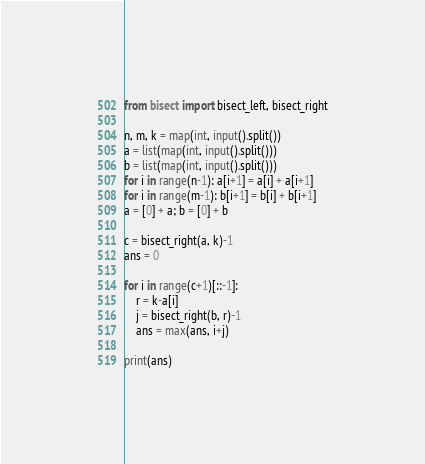Convert code to text. <code><loc_0><loc_0><loc_500><loc_500><_Python_>from bisect import bisect_left, bisect_right

n, m, k = map(int, input().split())
a = list(map(int, input().split()))
b = list(map(int, input().split()))
for i in range(n-1): a[i+1] = a[i] + a[i+1]
for i in range(m-1): b[i+1] = b[i] + b[i+1]
a = [0] + a; b = [0] + b

c = bisect_right(a, k)-1
ans = 0

for i in range(c+1)[::-1]:
    r = k-a[i]
    j = bisect_right(b, r)-1
    ans = max(ans, i+j)

print(ans)
</code> 